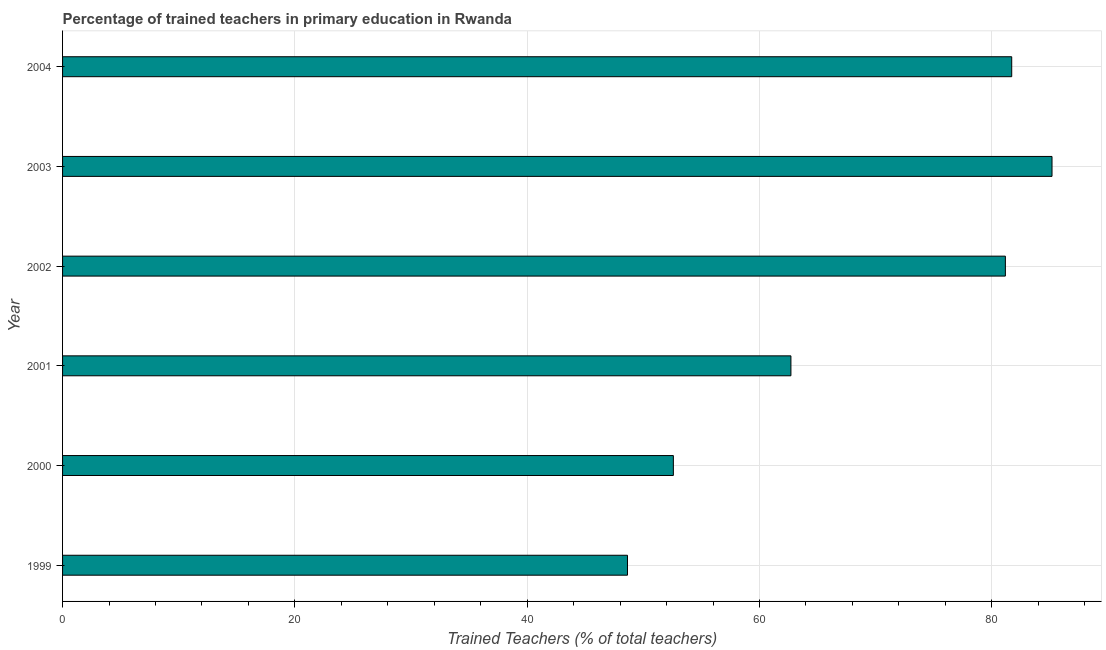Does the graph contain grids?
Your answer should be compact. Yes. What is the title of the graph?
Your answer should be compact. Percentage of trained teachers in primary education in Rwanda. What is the label or title of the X-axis?
Make the answer very short. Trained Teachers (% of total teachers). What is the percentage of trained teachers in 2001?
Keep it short and to the point. 62.7. Across all years, what is the maximum percentage of trained teachers?
Keep it short and to the point. 85.18. Across all years, what is the minimum percentage of trained teachers?
Your response must be concise. 48.63. In which year was the percentage of trained teachers minimum?
Your answer should be very brief. 1999. What is the sum of the percentage of trained teachers?
Your answer should be compact. 411.98. What is the difference between the percentage of trained teachers in 2000 and 2002?
Provide a short and direct response. -28.58. What is the average percentage of trained teachers per year?
Offer a very short reply. 68.66. What is the median percentage of trained teachers?
Your answer should be very brief. 71.94. In how many years, is the percentage of trained teachers greater than 8 %?
Keep it short and to the point. 6. Do a majority of the years between 2003 and 2001 (inclusive) have percentage of trained teachers greater than 68 %?
Your answer should be compact. Yes. What is the ratio of the percentage of trained teachers in 1999 to that in 2004?
Provide a short and direct response. 0.59. Is the percentage of trained teachers in 2002 less than that in 2004?
Keep it short and to the point. Yes. Is the difference between the percentage of trained teachers in 1999 and 2002 greater than the difference between any two years?
Provide a succinct answer. No. What is the difference between the highest and the second highest percentage of trained teachers?
Make the answer very short. 3.47. Is the sum of the percentage of trained teachers in 2003 and 2004 greater than the maximum percentage of trained teachers across all years?
Make the answer very short. Yes. What is the difference between the highest and the lowest percentage of trained teachers?
Give a very brief answer. 36.55. In how many years, is the percentage of trained teachers greater than the average percentage of trained teachers taken over all years?
Provide a short and direct response. 3. How many years are there in the graph?
Offer a terse response. 6. What is the difference between two consecutive major ticks on the X-axis?
Keep it short and to the point. 20. What is the Trained Teachers (% of total teachers) of 1999?
Your answer should be compact. 48.63. What is the Trained Teachers (% of total teachers) in 2000?
Ensure brevity in your answer.  52.58. What is the Trained Teachers (% of total teachers) of 2001?
Make the answer very short. 62.7. What is the Trained Teachers (% of total teachers) of 2002?
Provide a succinct answer. 81.17. What is the Trained Teachers (% of total teachers) in 2003?
Keep it short and to the point. 85.18. What is the Trained Teachers (% of total teachers) in 2004?
Keep it short and to the point. 81.71. What is the difference between the Trained Teachers (% of total teachers) in 1999 and 2000?
Your answer should be very brief. -3.95. What is the difference between the Trained Teachers (% of total teachers) in 1999 and 2001?
Make the answer very short. -14.07. What is the difference between the Trained Teachers (% of total teachers) in 1999 and 2002?
Make the answer very short. -32.53. What is the difference between the Trained Teachers (% of total teachers) in 1999 and 2003?
Your answer should be compact. -36.55. What is the difference between the Trained Teachers (% of total teachers) in 1999 and 2004?
Keep it short and to the point. -33.08. What is the difference between the Trained Teachers (% of total teachers) in 2000 and 2001?
Offer a very short reply. -10.12. What is the difference between the Trained Teachers (% of total teachers) in 2000 and 2002?
Offer a terse response. -28.58. What is the difference between the Trained Teachers (% of total teachers) in 2000 and 2003?
Provide a short and direct response. -32.6. What is the difference between the Trained Teachers (% of total teachers) in 2000 and 2004?
Your answer should be very brief. -29.13. What is the difference between the Trained Teachers (% of total teachers) in 2001 and 2002?
Provide a succinct answer. -18.46. What is the difference between the Trained Teachers (% of total teachers) in 2001 and 2003?
Your answer should be very brief. -22.48. What is the difference between the Trained Teachers (% of total teachers) in 2001 and 2004?
Offer a very short reply. -19.01. What is the difference between the Trained Teachers (% of total teachers) in 2002 and 2003?
Your answer should be very brief. -4.02. What is the difference between the Trained Teachers (% of total teachers) in 2002 and 2004?
Keep it short and to the point. -0.54. What is the difference between the Trained Teachers (% of total teachers) in 2003 and 2004?
Provide a short and direct response. 3.47. What is the ratio of the Trained Teachers (% of total teachers) in 1999 to that in 2000?
Make the answer very short. 0.93. What is the ratio of the Trained Teachers (% of total teachers) in 1999 to that in 2001?
Offer a very short reply. 0.78. What is the ratio of the Trained Teachers (% of total teachers) in 1999 to that in 2002?
Provide a succinct answer. 0.6. What is the ratio of the Trained Teachers (% of total teachers) in 1999 to that in 2003?
Make the answer very short. 0.57. What is the ratio of the Trained Teachers (% of total teachers) in 1999 to that in 2004?
Offer a terse response. 0.59. What is the ratio of the Trained Teachers (% of total teachers) in 2000 to that in 2001?
Your response must be concise. 0.84. What is the ratio of the Trained Teachers (% of total teachers) in 2000 to that in 2002?
Make the answer very short. 0.65. What is the ratio of the Trained Teachers (% of total teachers) in 2000 to that in 2003?
Your answer should be compact. 0.62. What is the ratio of the Trained Teachers (% of total teachers) in 2000 to that in 2004?
Ensure brevity in your answer.  0.64. What is the ratio of the Trained Teachers (% of total teachers) in 2001 to that in 2002?
Your answer should be very brief. 0.77. What is the ratio of the Trained Teachers (% of total teachers) in 2001 to that in 2003?
Provide a short and direct response. 0.74. What is the ratio of the Trained Teachers (% of total teachers) in 2001 to that in 2004?
Offer a very short reply. 0.77. What is the ratio of the Trained Teachers (% of total teachers) in 2002 to that in 2003?
Keep it short and to the point. 0.95. What is the ratio of the Trained Teachers (% of total teachers) in 2002 to that in 2004?
Offer a terse response. 0.99. What is the ratio of the Trained Teachers (% of total teachers) in 2003 to that in 2004?
Make the answer very short. 1.04. 